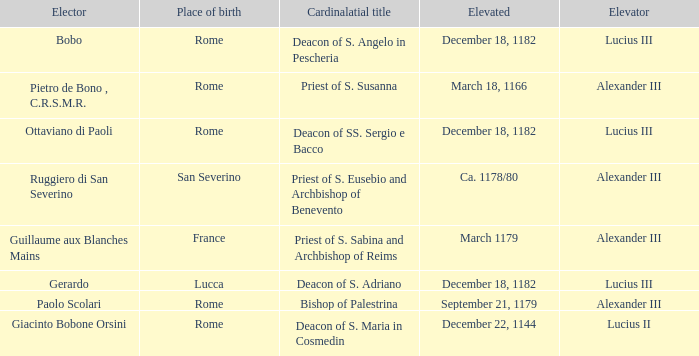What Elector has an Elevator of Alexander III and a Cardinalatial title of Bishop of Palestrina? Paolo Scolari. 